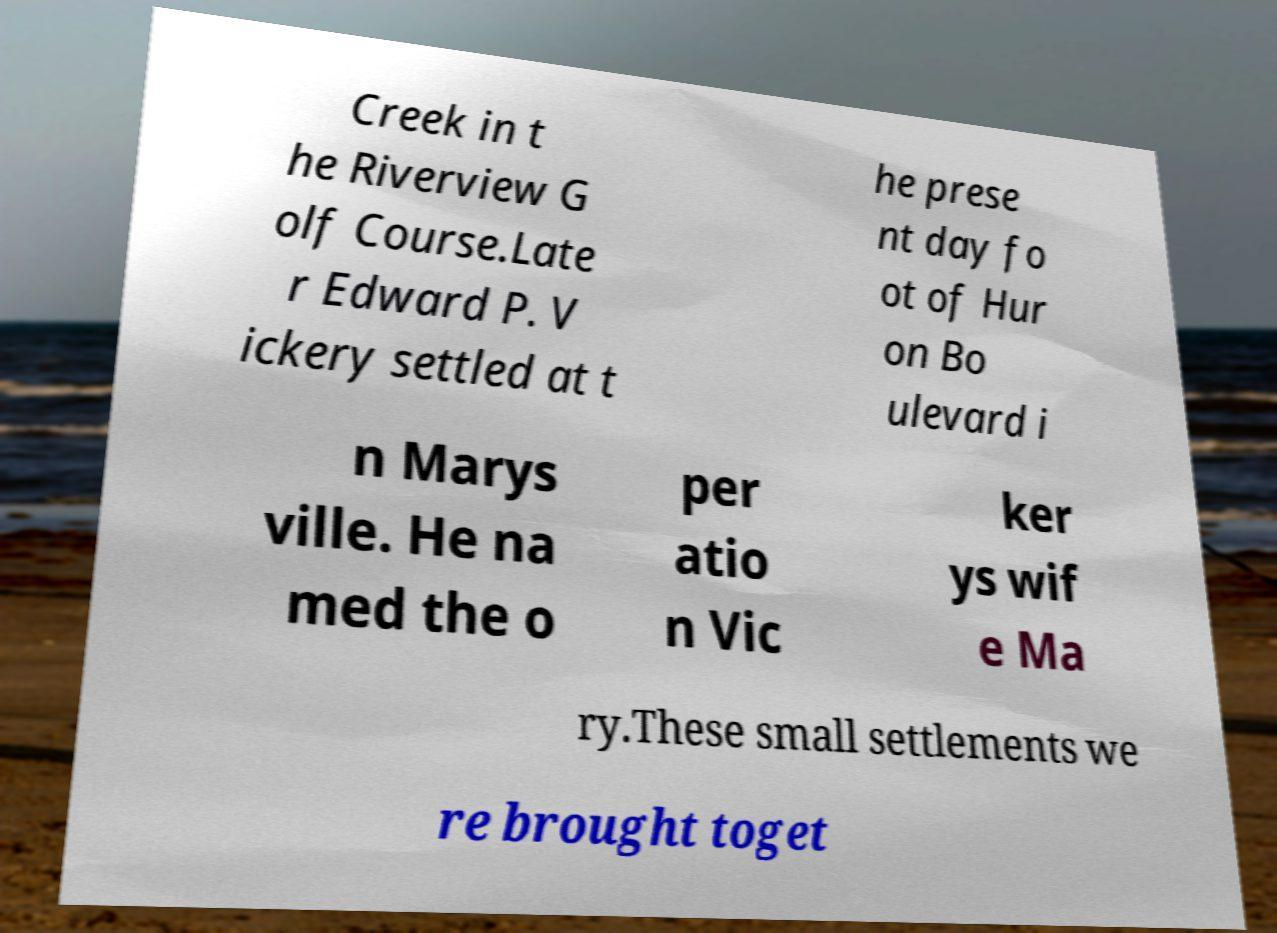Can you accurately transcribe the text from the provided image for me? Creek in t he Riverview G olf Course.Late r Edward P. V ickery settled at t he prese nt day fo ot of Hur on Bo ulevard i n Marys ville. He na med the o per atio n Vic ker ys wif e Ma ry.These small settlements we re brought toget 